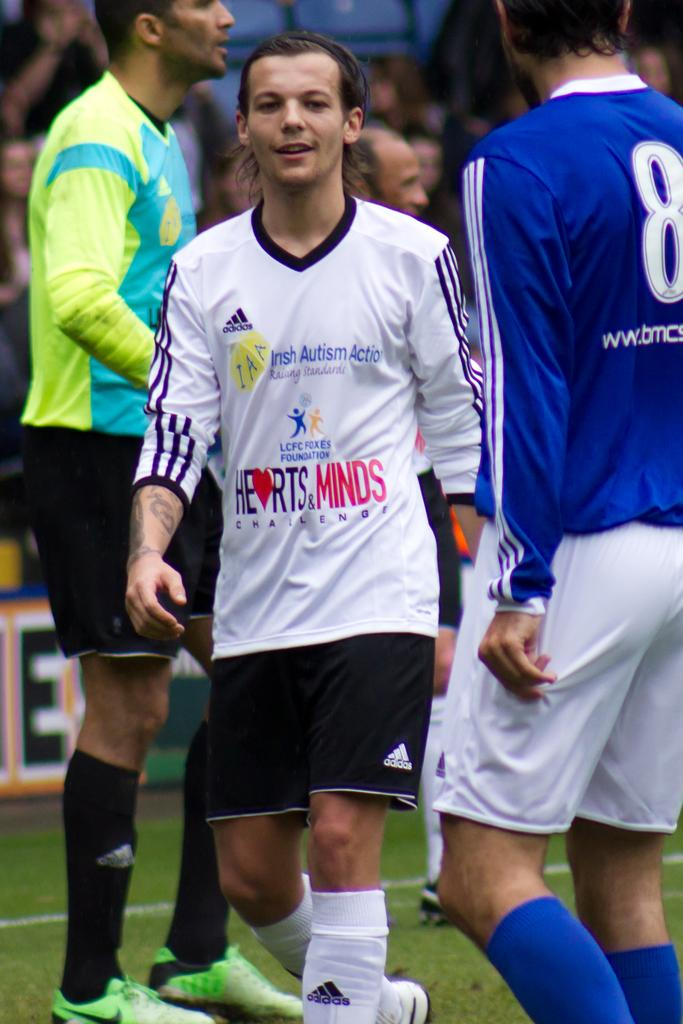<image>
Give a short and clear explanation of the subsequent image. A kid wears a jersey that has a logo for Irish Autism Action on the front. 